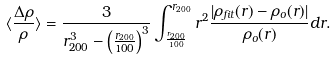<formula> <loc_0><loc_0><loc_500><loc_500>\langle \frac { \Delta \rho } { \rho } \rangle = \frac { 3 } { r _ { 2 0 0 } ^ { 3 } - \left ( \frac { r _ { 2 0 0 } } { 1 0 0 } \right ) ^ { 3 } } \int _ { \frac { r _ { 2 0 0 } } { 1 0 0 } } ^ { r _ { 2 0 0 } } r ^ { 2 } \frac { | \rho _ { f i t } ( r ) - \rho _ { o } ( r ) | } { \rho _ { o } ( r ) } d r .</formula> 